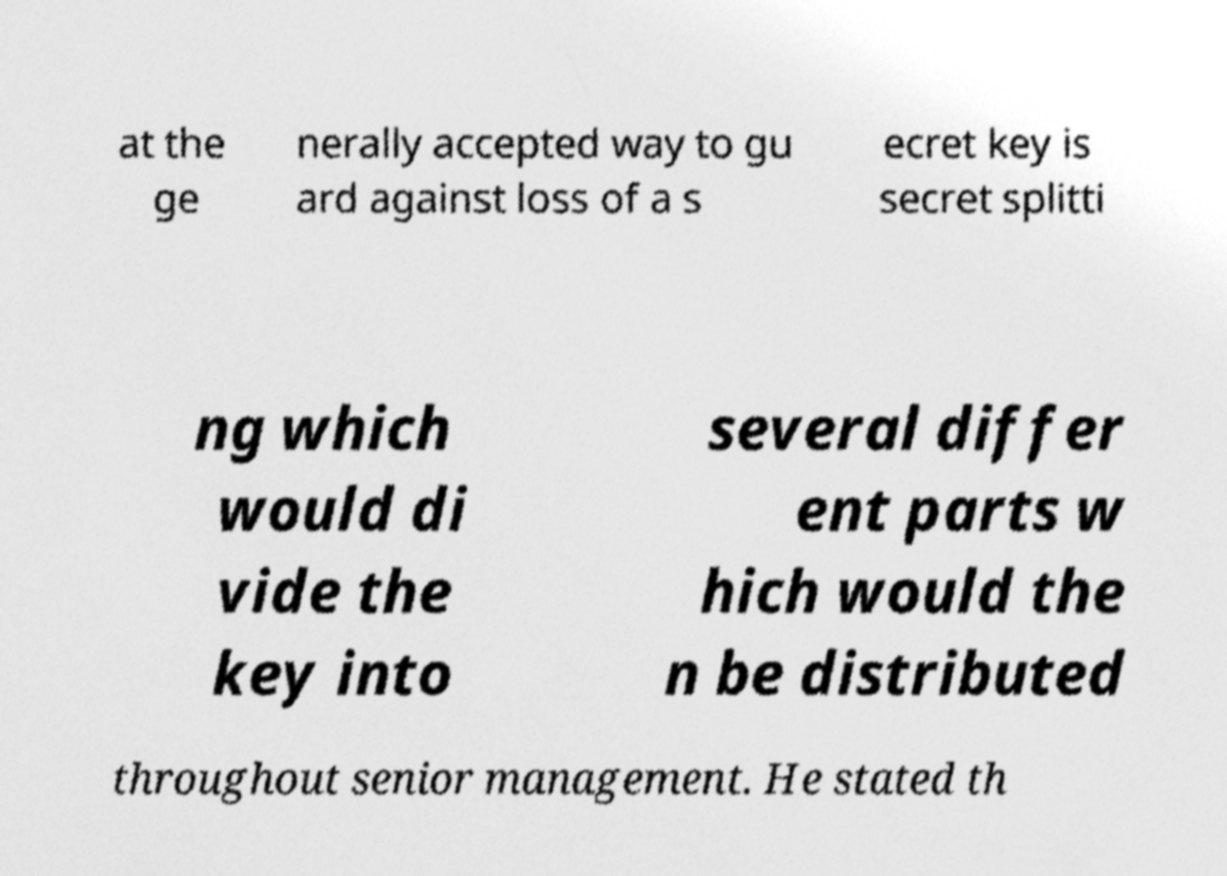Could you extract and type out the text from this image? at the ge nerally accepted way to gu ard against loss of a s ecret key is secret splitti ng which would di vide the key into several differ ent parts w hich would the n be distributed throughout senior management. He stated th 